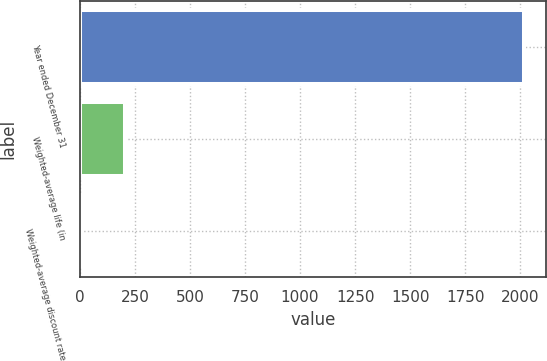Convert chart. <chart><loc_0><loc_0><loc_500><loc_500><bar_chart><fcel>Year ended December 31<fcel>Weighted-average life (in<fcel>Weighted-average discount rate<nl><fcel>2017<fcel>204.31<fcel>2.9<nl></chart> 